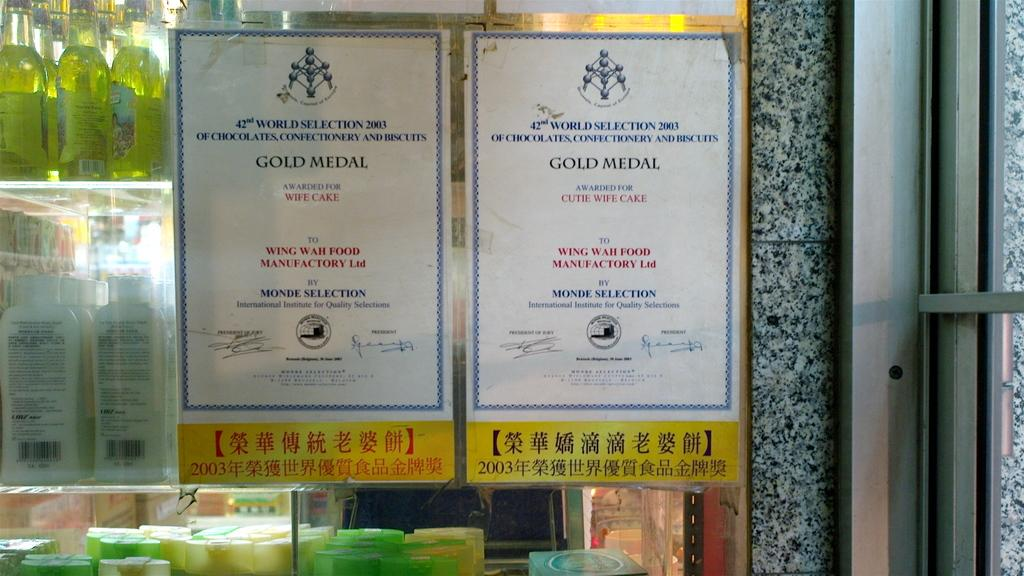<image>
Describe the image concisely. Two signs that read Gold Medal for wife cake and cute wife cake 